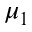Convert formula to latex. <formula><loc_0><loc_0><loc_500><loc_500>\mu _ { 1 }</formula> 